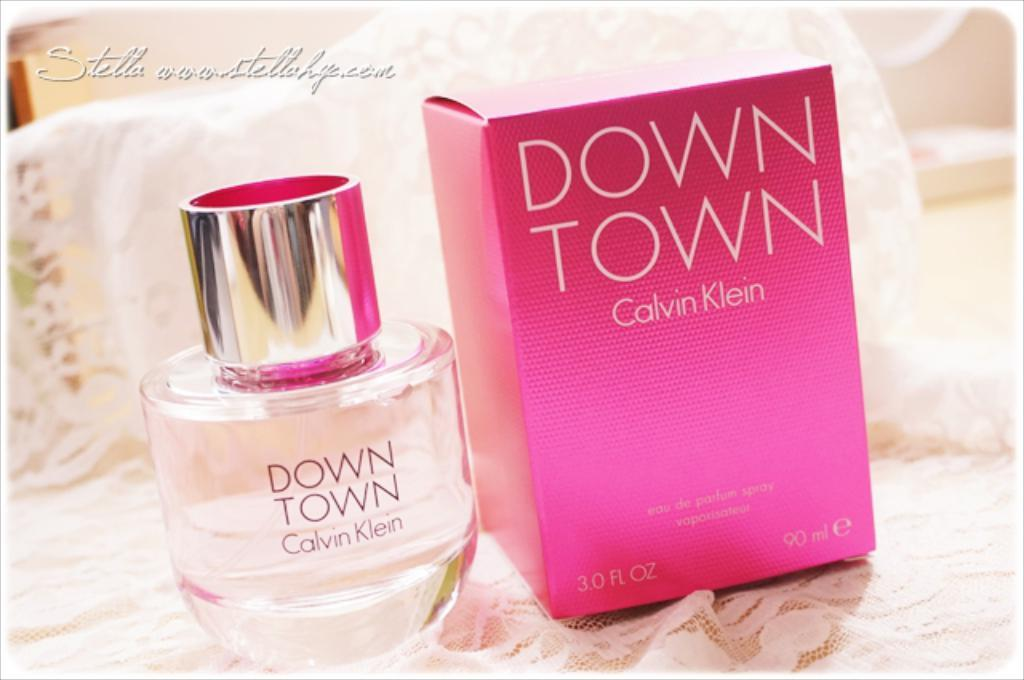<image>
Relay a brief, clear account of the picture shown. Bottle of Down Town next to a pink box. 